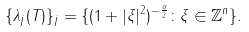<formula> <loc_0><loc_0><loc_500><loc_500>\{ \lambda _ { j } ( { T } ) \} _ { j } = \{ ( 1 + | \xi | ^ { 2 } ) ^ { - \frac { \alpha } { 2 } } \colon \xi \in \mathbb { Z } ^ { n } \} .</formula> 